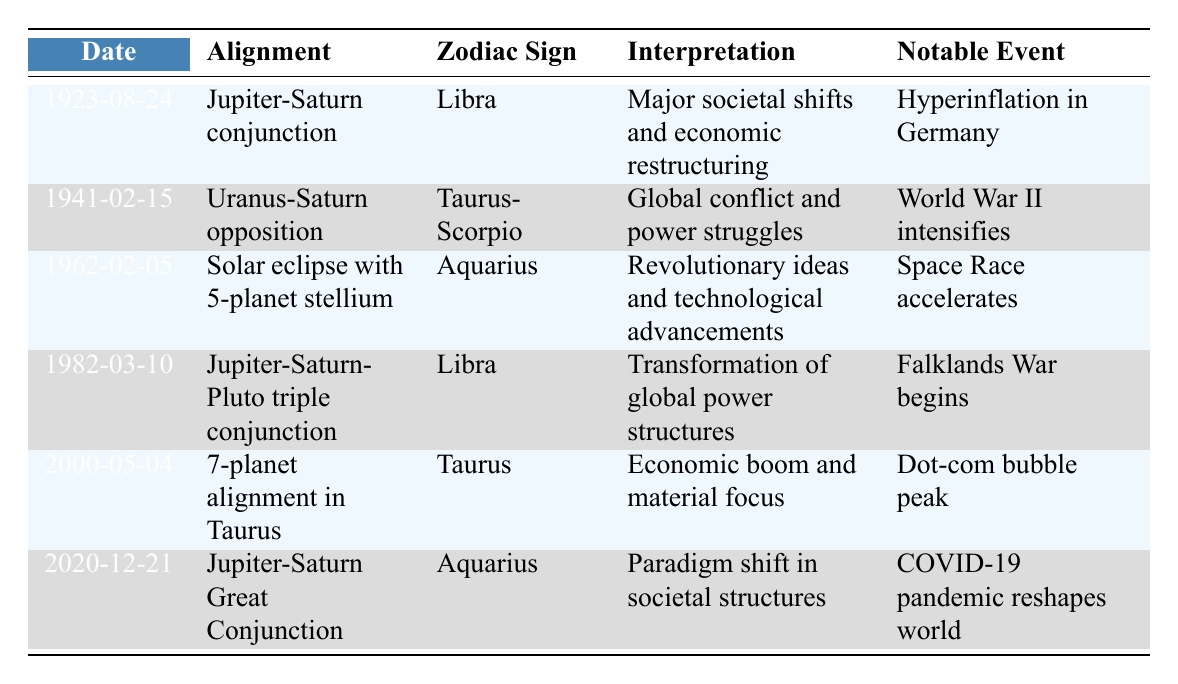What planetary alignment occurred on August 24, 1923? The table lists the date in the first column, which indicates that the alignment on August 24, 1923, is the Jupiter-Saturn conjunction.
Answer: Jupiter-Saturn conjunction What zodiac sign corresponds to the alignment on February 15, 1941? Checking the date in the table, we see that the alignment on February 15, 1941, corresponds to the zodiac signs Taurus-Scorpio.
Answer: Taurus-Scorpio Which notable event is associated with the 1962 solar eclipse? The table shows that the notable event linked to the solar eclipse with a 5-planet stellium on February 5, 1962, is that the Space Race accelerates.
Answer: Space Race accelerates Was there a major event in Germany associated with the 1923 alignment? According to the table, the notable event surrounding the Jupiter-Saturn conjunction in 1923 was hyperinflation in Germany, confirming that there was indeed a significant event.
Answer: Yes Identify the interpretations linked to the 2000 planetary alignment. The table indicates that on May 4, 2000, the interpretation associated with the 7-planet alignment is an economic boom and material focus.
Answer: Economic boom and material focus How many alignments in the table reference the zodiac sign Aquarius? The table shows two entries with the zodiac sign Aquarius, which are the solar eclipse on February 5, 1962, and the Jupiter-Saturn Great Conjunction on December 21, 2020.
Answer: 2 What was the notable event during the Jupiter-Saturn Great Conjunction? From the table, the notable event connected to the Jupiter-Saturn Great Conjunction on December 21, 2020, is the reshaping of the world due to the COVID-19 pandemic.
Answer: COVID-19 pandemic reshapes world During which alignment did significant global conflicts occur, and what was the alignment? The table indicates that the Uranus-Saturn opposition on February 15, 1941, is associated with global conflict and power struggles, notably with World War II intensifying.
Answer: Uranus-Saturn opposition What is the earliest date listed in the table, and what is its interpretation? The earliest date in the table is August 24, 1923, with the interpretation being major societal shifts and economic restructuring following the Jupiter-Saturn conjunction.
Answer: Major societal shifts and economic restructuring Calculate the average date of the notable events listed in the table. The table contains six notable events, spanning from 1923 to 2020. Overlaying the years gives us a total of 1923 + 1941 + 1962 + 1982 + 2000 + 2020 = 10228; dividing by 6 yields approximately 1704.67, which does not represent a specific date since it's not a year. Therefore, it can be deduced that this requires contextual reasoning rather than a direct calculation of average.
Answer: Not applicable, requires contextual reasoning 